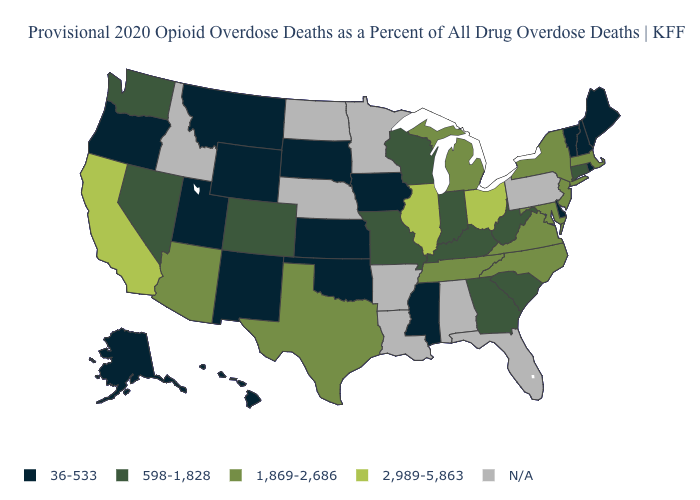What is the highest value in the USA?
Quick response, please. 2,989-5,863. Which states hav the highest value in the Northeast?
Be succinct. Massachusetts, New Jersey, New York. What is the value of West Virginia?
Keep it brief. 598-1,828. Name the states that have a value in the range 36-533?
Concise answer only. Alaska, Delaware, Hawaii, Iowa, Kansas, Maine, Mississippi, Montana, New Hampshire, New Mexico, Oklahoma, Oregon, Rhode Island, South Dakota, Utah, Vermont, Wyoming. Does the map have missing data?
Short answer required. Yes. What is the value of Utah?
Quick response, please. 36-533. What is the value of Louisiana?
Concise answer only. N/A. Among the states that border Iowa , which have the lowest value?
Be succinct. South Dakota. What is the highest value in states that border Idaho?
Concise answer only. 598-1,828. Does New York have the highest value in the Northeast?
Keep it brief. Yes. Name the states that have a value in the range N/A?
Answer briefly. Alabama, Arkansas, Florida, Idaho, Louisiana, Minnesota, Nebraska, North Dakota, Pennsylvania. Does Alaska have the lowest value in the USA?
Short answer required. Yes. What is the value of Colorado?
Short answer required. 598-1,828. What is the value of Tennessee?
Concise answer only. 1,869-2,686. What is the lowest value in the Northeast?
Answer briefly. 36-533. 